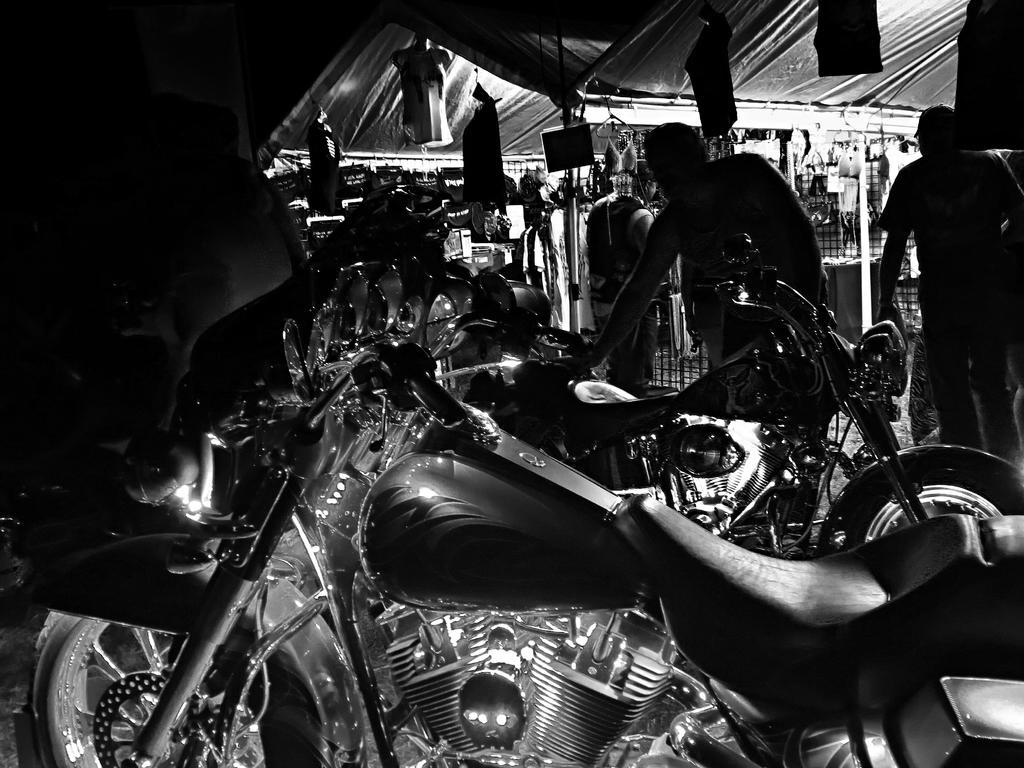Could you give a brief overview of what you see in this image? This is black and white picture where we can see bikes. Right side of the image men are there. Top of the image shelter is there and things are hanging to the shelter. 